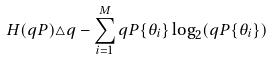<formula> <loc_0><loc_0><loc_500><loc_500>H ( q P ) \triangle q - \sum _ { i = 1 } ^ { M } q P \{ \theta _ { i } \} \log _ { 2 } ( q P \{ \theta _ { i } \} )</formula> 